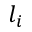Convert formula to latex. <formula><loc_0><loc_0><loc_500><loc_500>l _ { i }</formula> 